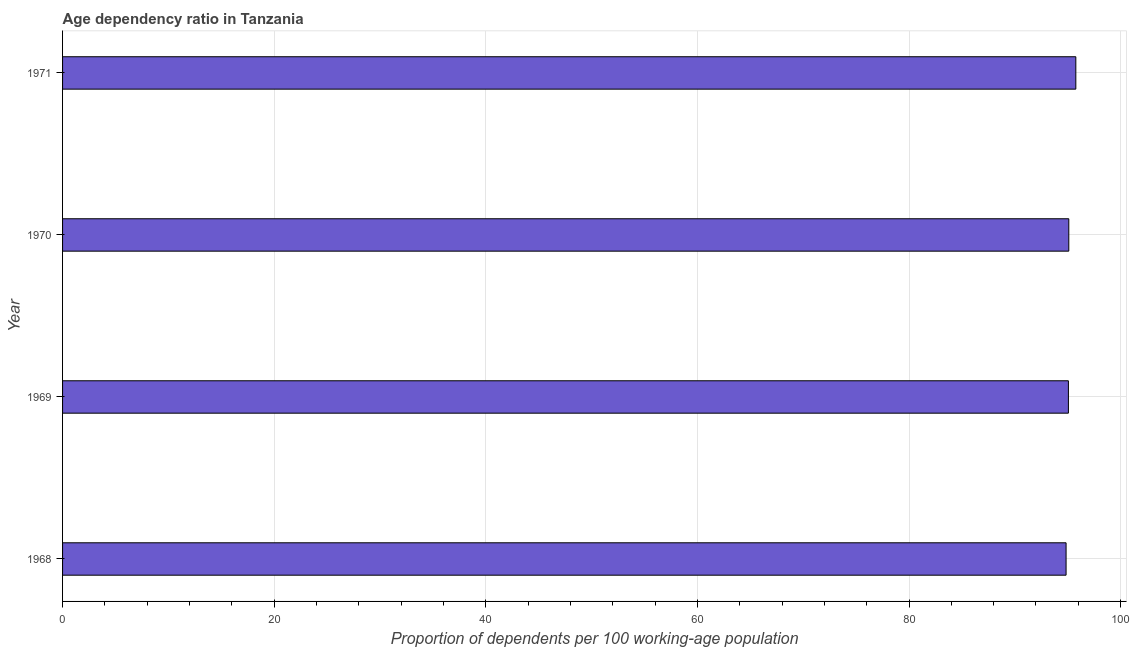Does the graph contain any zero values?
Give a very brief answer. No. What is the title of the graph?
Your answer should be very brief. Age dependency ratio in Tanzania. What is the label or title of the X-axis?
Provide a succinct answer. Proportion of dependents per 100 working-age population. What is the age dependency ratio in 1971?
Your response must be concise. 95.77. Across all years, what is the maximum age dependency ratio?
Make the answer very short. 95.77. Across all years, what is the minimum age dependency ratio?
Your answer should be compact. 94.85. In which year was the age dependency ratio minimum?
Provide a succinct answer. 1968. What is the sum of the age dependency ratio?
Your answer should be very brief. 380.78. What is the difference between the age dependency ratio in 1968 and 1971?
Provide a succinct answer. -0.92. What is the average age dependency ratio per year?
Ensure brevity in your answer.  95.2. What is the median age dependency ratio?
Your response must be concise. 95.08. In how many years, is the age dependency ratio greater than 32 ?
Offer a very short reply. 4. What is the ratio of the age dependency ratio in 1969 to that in 1971?
Provide a short and direct response. 0.99. Is the age dependency ratio in 1970 less than that in 1971?
Provide a short and direct response. Yes. What is the difference between the highest and the second highest age dependency ratio?
Give a very brief answer. 0.67. Is the sum of the age dependency ratio in 1969 and 1971 greater than the maximum age dependency ratio across all years?
Give a very brief answer. Yes. In how many years, is the age dependency ratio greater than the average age dependency ratio taken over all years?
Give a very brief answer. 1. How many bars are there?
Keep it short and to the point. 4. What is the difference between two consecutive major ticks on the X-axis?
Provide a succinct answer. 20. Are the values on the major ticks of X-axis written in scientific E-notation?
Your response must be concise. No. What is the Proportion of dependents per 100 working-age population of 1968?
Offer a terse response. 94.85. What is the Proportion of dependents per 100 working-age population of 1969?
Offer a very short reply. 95.07. What is the Proportion of dependents per 100 working-age population of 1970?
Your answer should be very brief. 95.1. What is the Proportion of dependents per 100 working-age population of 1971?
Provide a succinct answer. 95.77. What is the difference between the Proportion of dependents per 100 working-age population in 1968 and 1969?
Provide a short and direct response. -0.22. What is the difference between the Proportion of dependents per 100 working-age population in 1968 and 1970?
Your response must be concise. -0.26. What is the difference between the Proportion of dependents per 100 working-age population in 1968 and 1971?
Provide a short and direct response. -0.92. What is the difference between the Proportion of dependents per 100 working-age population in 1969 and 1970?
Your answer should be very brief. -0.04. What is the difference between the Proportion of dependents per 100 working-age population in 1969 and 1971?
Your answer should be very brief. -0.7. What is the difference between the Proportion of dependents per 100 working-age population in 1970 and 1971?
Your answer should be very brief. -0.66. What is the ratio of the Proportion of dependents per 100 working-age population in 1968 to that in 1969?
Give a very brief answer. 1. What is the ratio of the Proportion of dependents per 100 working-age population in 1968 to that in 1970?
Offer a terse response. 1. What is the ratio of the Proportion of dependents per 100 working-age population in 1968 to that in 1971?
Offer a terse response. 0.99. 